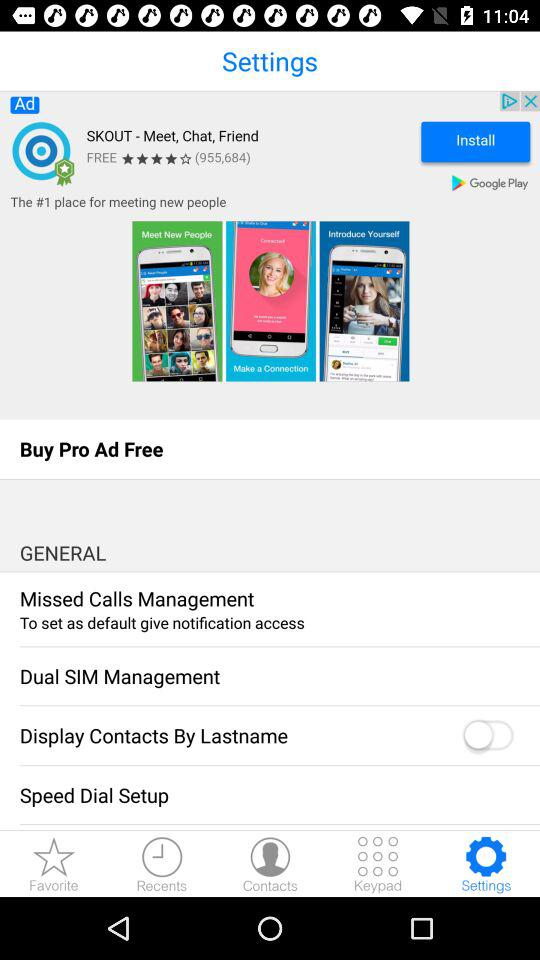What is the app name? The app name is "SKOUT - Meet, Chat, Friend". 